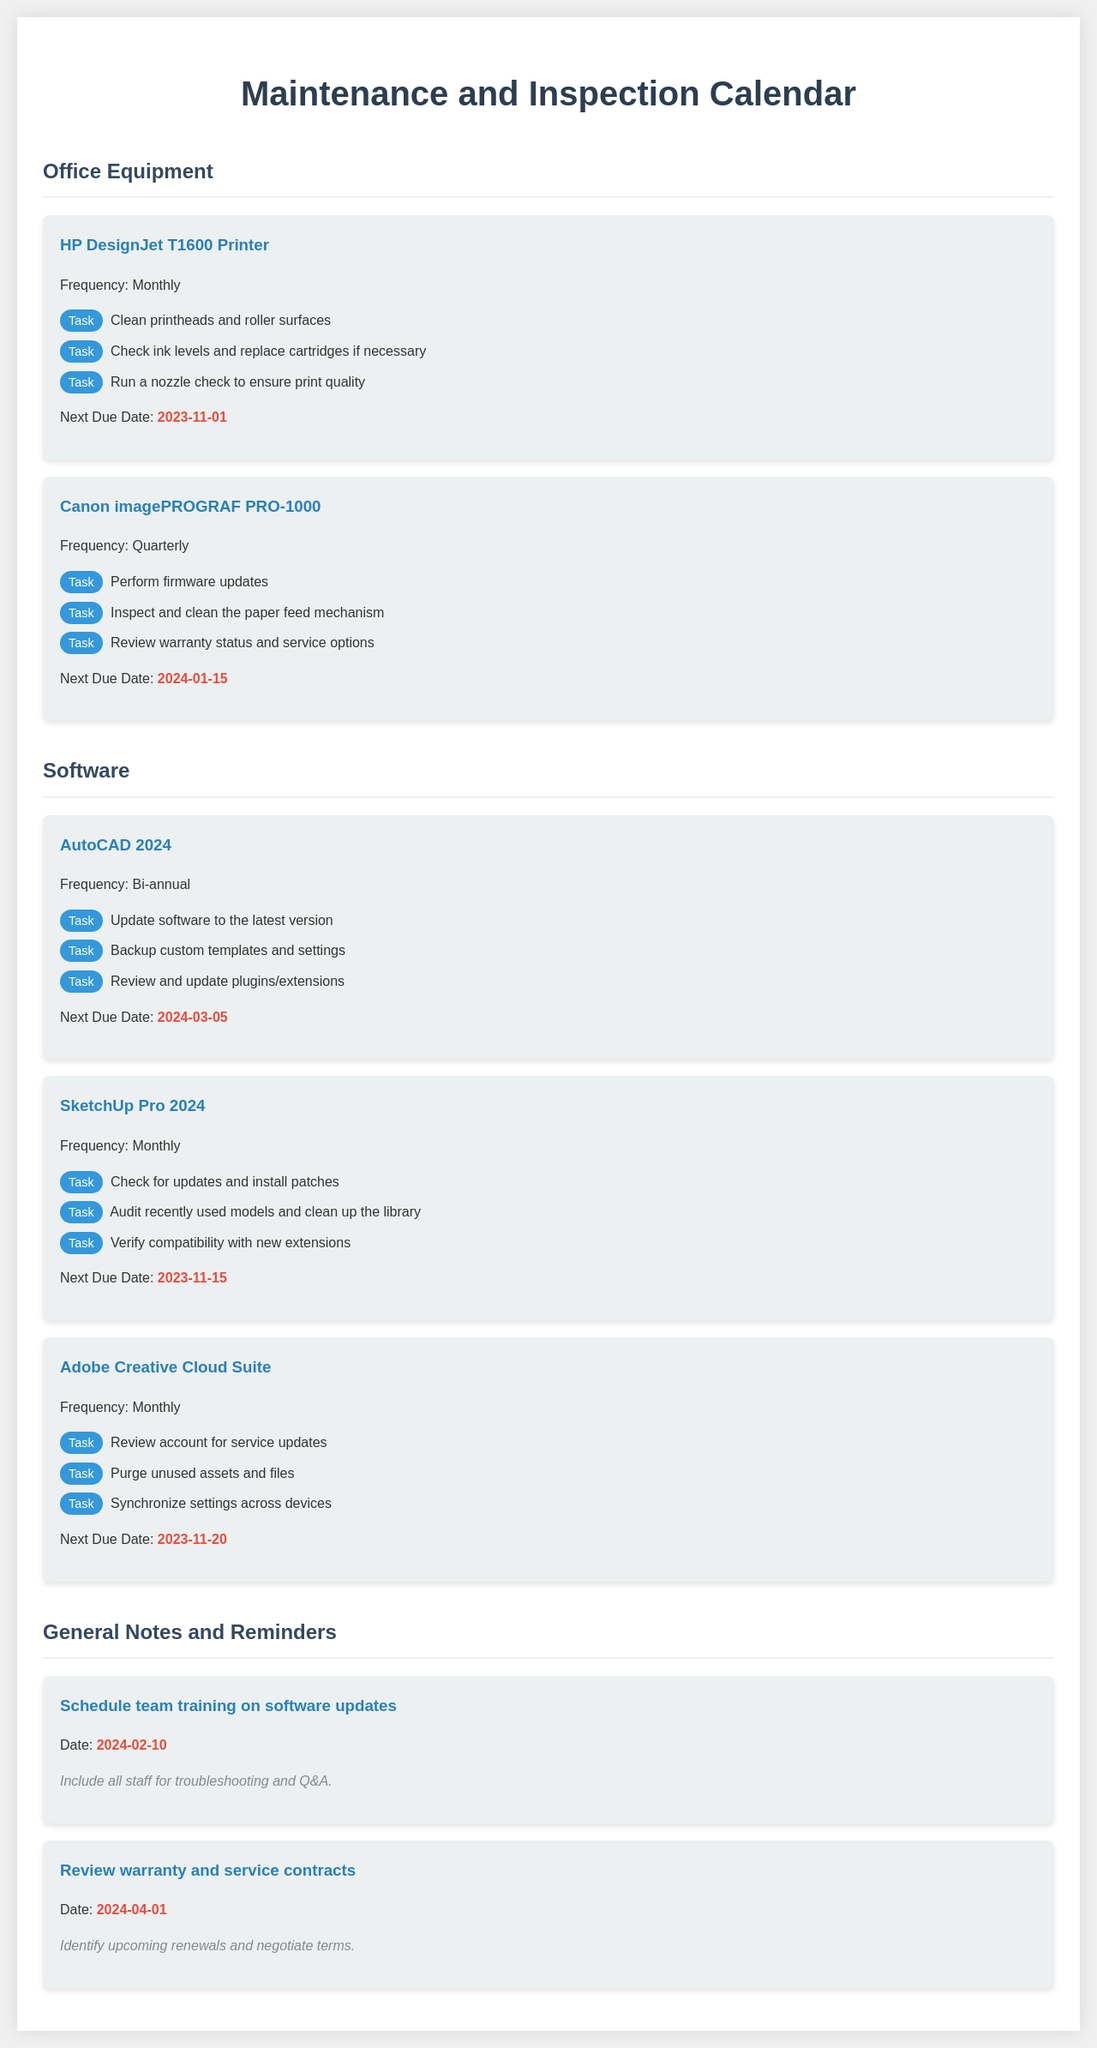What is the next due date for the HP DesignJet T1600 Printer? The next due date for the HP DesignJet T1600 Printer is directly stated in the document.
Answer: 2023-11-01 What are the tasks for the Canon imagePROGRAF PRO-1000? The document lists specific tasks for this printer, requiring review for proper maintenance.
Answer: Perform firmware updates, Inspect and clean the paper feed mechanism, Review warranty status and service options How often should SketchUp Pro 2024 be updated? The frequency of updates for SketchUp Pro 2024 is mentioned clearly in the document.
Answer: Monthly When is the team training on software updates scheduled? The date for the team training is specified in the notes section of the document.
Answer: 2024-02-10 Which software requires a backup of custom templates and settings? Identifying the software that requires this task is straightforward based on the list provided.
Answer: AutoCAD 2024 What color is used for the task labels in the document? The document includes specific formatting details regarding the labels used for tasks.
Answer: White What is the frequency of maintenance for Adobe Creative Cloud Suite? The frequency for Adobe Creative Cloud Suite is clearly defined in the document.
Answer: Monthly What should be done on the next check for the Canon imagePROGRAF PRO-1000? Requires understanding the next due date and expected tasks due by that date.
Answer: Perform firmware updates What is one of the general notes regarding warranties? The document outlines notes concerning warranties, which is essential for maintenance awareness.
Answer: Identify upcoming renewals and negotiate terms 